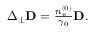Convert formula to latex. <formula><loc_0><loc_0><loc_500><loc_500>\begin{array} { r } { \Delta _ { \perp } \mathbf D = \frac { n _ { e } ^ { ( 0 ) } } { \gamma _ { 0 } } D . } \end{array}</formula> 